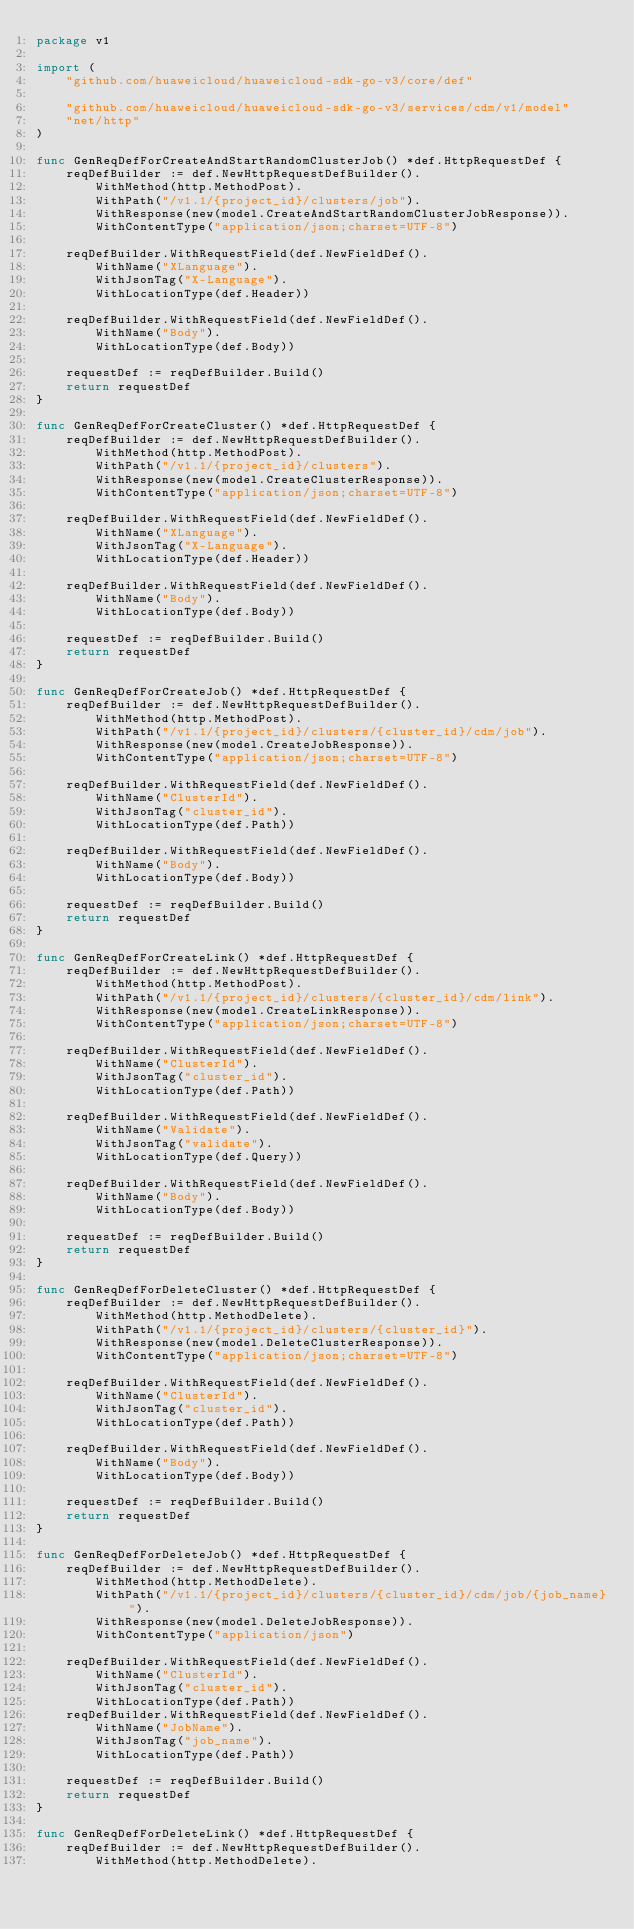Convert code to text. <code><loc_0><loc_0><loc_500><loc_500><_Go_>package v1

import (
	"github.com/huaweicloud/huaweicloud-sdk-go-v3/core/def"

	"github.com/huaweicloud/huaweicloud-sdk-go-v3/services/cdm/v1/model"
	"net/http"
)

func GenReqDefForCreateAndStartRandomClusterJob() *def.HttpRequestDef {
	reqDefBuilder := def.NewHttpRequestDefBuilder().
		WithMethod(http.MethodPost).
		WithPath("/v1.1/{project_id}/clusters/job").
		WithResponse(new(model.CreateAndStartRandomClusterJobResponse)).
		WithContentType("application/json;charset=UTF-8")

	reqDefBuilder.WithRequestField(def.NewFieldDef().
		WithName("XLanguage").
		WithJsonTag("X-Language").
		WithLocationType(def.Header))

	reqDefBuilder.WithRequestField(def.NewFieldDef().
		WithName("Body").
		WithLocationType(def.Body))

	requestDef := reqDefBuilder.Build()
	return requestDef
}

func GenReqDefForCreateCluster() *def.HttpRequestDef {
	reqDefBuilder := def.NewHttpRequestDefBuilder().
		WithMethod(http.MethodPost).
		WithPath("/v1.1/{project_id}/clusters").
		WithResponse(new(model.CreateClusterResponse)).
		WithContentType("application/json;charset=UTF-8")

	reqDefBuilder.WithRequestField(def.NewFieldDef().
		WithName("XLanguage").
		WithJsonTag("X-Language").
		WithLocationType(def.Header))

	reqDefBuilder.WithRequestField(def.NewFieldDef().
		WithName("Body").
		WithLocationType(def.Body))

	requestDef := reqDefBuilder.Build()
	return requestDef
}

func GenReqDefForCreateJob() *def.HttpRequestDef {
	reqDefBuilder := def.NewHttpRequestDefBuilder().
		WithMethod(http.MethodPost).
		WithPath("/v1.1/{project_id}/clusters/{cluster_id}/cdm/job").
		WithResponse(new(model.CreateJobResponse)).
		WithContentType("application/json;charset=UTF-8")

	reqDefBuilder.WithRequestField(def.NewFieldDef().
		WithName("ClusterId").
		WithJsonTag("cluster_id").
		WithLocationType(def.Path))

	reqDefBuilder.WithRequestField(def.NewFieldDef().
		WithName("Body").
		WithLocationType(def.Body))

	requestDef := reqDefBuilder.Build()
	return requestDef
}

func GenReqDefForCreateLink() *def.HttpRequestDef {
	reqDefBuilder := def.NewHttpRequestDefBuilder().
		WithMethod(http.MethodPost).
		WithPath("/v1.1/{project_id}/clusters/{cluster_id}/cdm/link").
		WithResponse(new(model.CreateLinkResponse)).
		WithContentType("application/json;charset=UTF-8")

	reqDefBuilder.WithRequestField(def.NewFieldDef().
		WithName("ClusterId").
		WithJsonTag("cluster_id").
		WithLocationType(def.Path))

	reqDefBuilder.WithRequestField(def.NewFieldDef().
		WithName("Validate").
		WithJsonTag("validate").
		WithLocationType(def.Query))

	reqDefBuilder.WithRequestField(def.NewFieldDef().
		WithName("Body").
		WithLocationType(def.Body))

	requestDef := reqDefBuilder.Build()
	return requestDef
}

func GenReqDefForDeleteCluster() *def.HttpRequestDef {
	reqDefBuilder := def.NewHttpRequestDefBuilder().
		WithMethod(http.MethodDelete).
		WithPath("/v1.1/{project_id}/clusters/{cluster_id}").
		WithResponse(new(model.DeleteClusterResponse)).
		WithContentType("application/json;charset=UTF-8")

	reqDefBuilder.WithRequestField(def.NewFieldDef().
		WithName("ClusterId").
		WithJsonTag("cluster_id").
		WithLocationType(def.Path))

	reqDefBuilder.WithRequestField(def.NewFieldDef().
		WithName("Body").
		WithLocationType(def.Body))

	requestDef := reqDefBuilder.Build()
	return requestDef
}

func GenReqDefForDeleteJob() *def.HttpRequestDef {
	reqDefBuilder := def.NewHttpRequestDefBuilder().
		WithMethod(http.MethodDelete).
		WithPath("/v1.1/{project_id}/clusters/{cluster_id}/cdm/job/{job_name}").
		WithResponse(new(model.DeleteJobResponse)).
		WithContentType("application/json")

	reqDefBuilder.WithRequestField(def.NewFieldDef().
		WithName("ClusterId").
		WithJsonTag("cluster_id").
		WithLocationType(def.Path))
	reqDefBuilder.WithRequestField(def.NewFieldDef().
		WithName("JobName").
		WithJsonTag("job_name").
		WithLocationType(def.Path))

	requestDef := reqDefBuilder.Build()
	return requestDef
}

func GenReqDefForDeleteLink() *def.HttpRequestDef {
	reqDefBuilder := def.NewHttpRequestDefBuilder().
		WithMethod(http.MethodDelete).</code> 